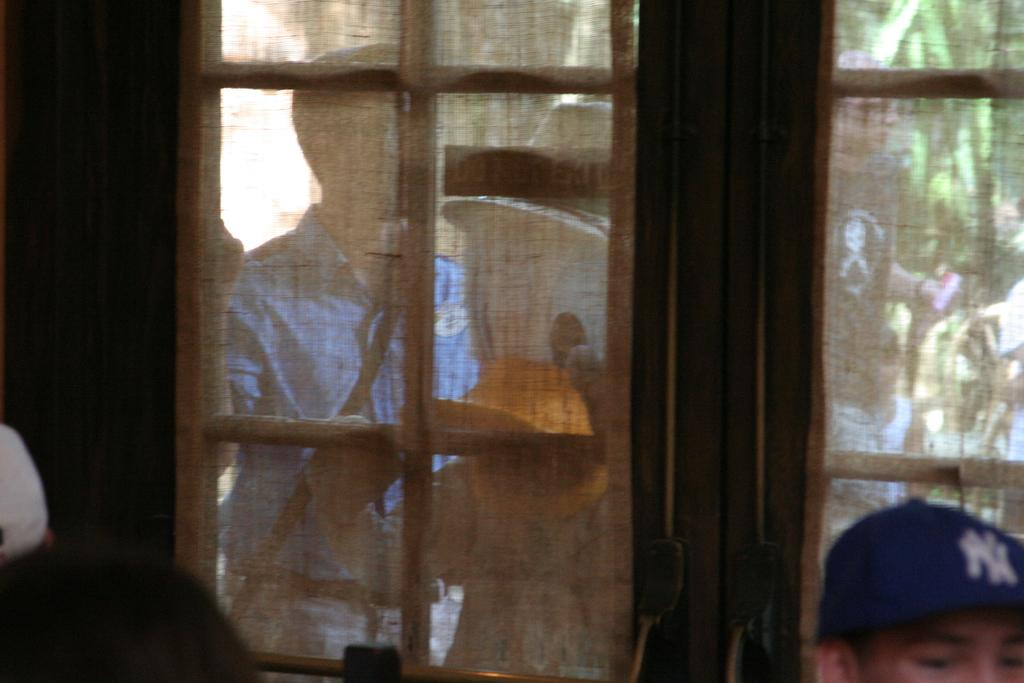Where was the image taken? The image was taken indoors. What can be seen in the foreground of the image? There is a door and a person standing on the ground in the foreground of the image. What is visible in the background of the image? There is a tree and other persons in the background of the image. Are there any other objects visible in the background of the image? Yes, there are other objects in the background of the image. What type of glue is being used by the person in the image? There is no glue present in the image, and no activity involving glue can be observed. 